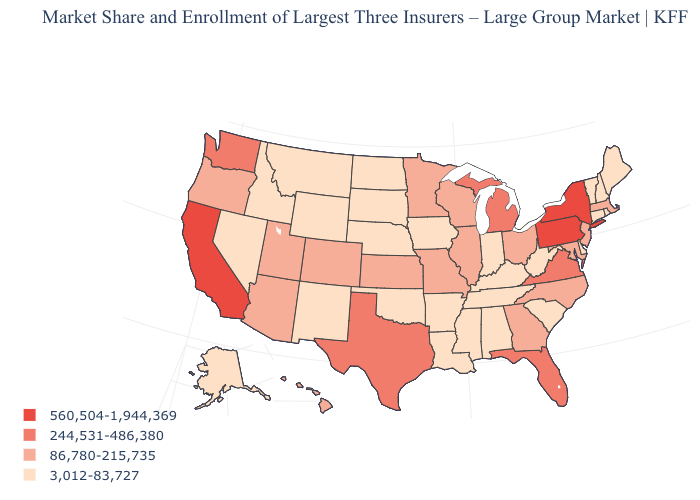What is the highest value in the West ?
Short answer required. 560,504-1,944,369. Does the first symbol in the legend represent the smallest category?
Keep it brief. No. Among the states that border Alabama , does Florida have the lowest value?
Concise answer only. No. Does Pennsylvania have the highest value in the USA?
Write a very short answer. Yes. Which states have the lowest value in the West?
Be succinct. Alaska, Idaho, Montana, Nevada, New Mexico, Wyoming. What is the highest value in the USA?
Be succinct. 560,504-1,944,369. Name the states that have a value in the range 3,012-83,727?
Give a very brief answer. Alabama, Alaska, Arkansas, Connecticut, Delaware, Idaho, Indiana, Iowa, Kentucky, Louisiana, Maine, Mississippi, Montana, Nebraska, Nevada, New Hampshire, New Mexico, North Dakota, Oklahoma, Rhode Island, South Carolina, South Dakota, Tennessee, Vermont, West Virginia, Wyoming. Among the states that border Nevada , does Utah have the lowest value?
Keep it brief. No. Does Ohio have the lowest value in the USA?
Give a very brief answer. No. What is the value of Michigan?
Answer briefly. 244,531-486,380. Among the states that border New Jersey , does Delaware have the highest value?
Concise answer only. No. What is the highest value in the West ?
Keep it brief. 560,504-1,944,369. Does Pennsylvania have the highest value in the USA?
Keep it brief. Yes. What is the value of New Jersey?
Give a very brief answer. 86,780-215,735. Does West Virginia have the highest value in the USA?
Quick response, please. No. 